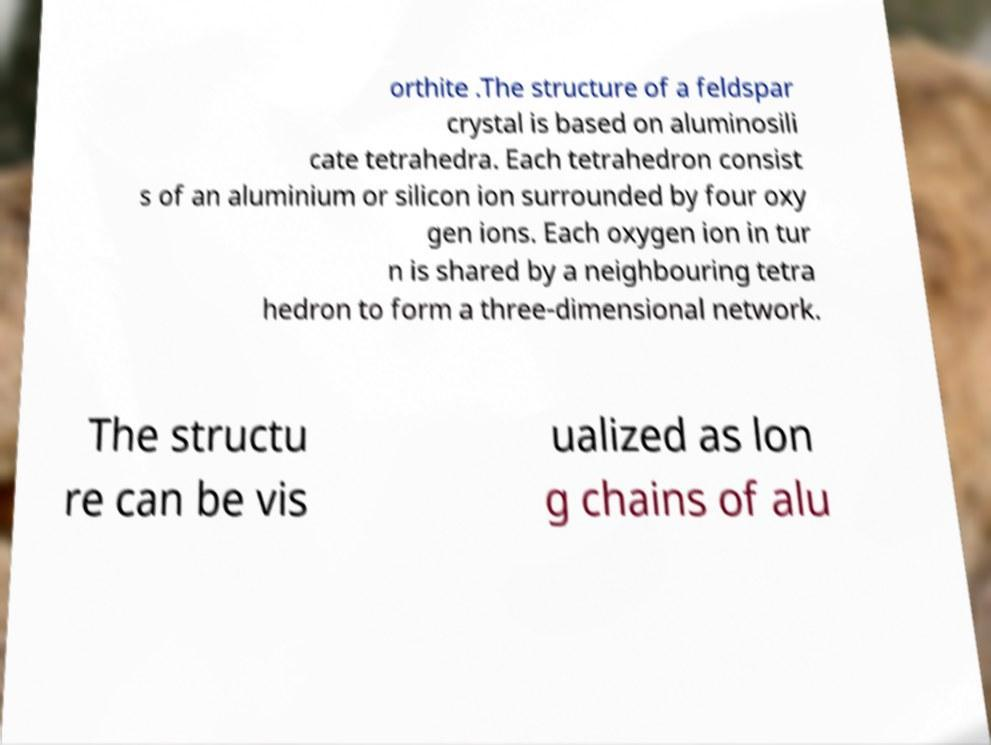I need the written content from this picture converted into text. Can you do that? orthite .The structure of a feldspar crystal is based on aluminosili cate tetrahedra. Each tetrahedron consist s of an aluminium or silicon ion surrounded by four oxy gen ions. Each oxygen ion in tur n is shared by a neighbouring tetra hedron to form a three-dimensional network. The structu re can be vis ualized as lon g chains of alu 